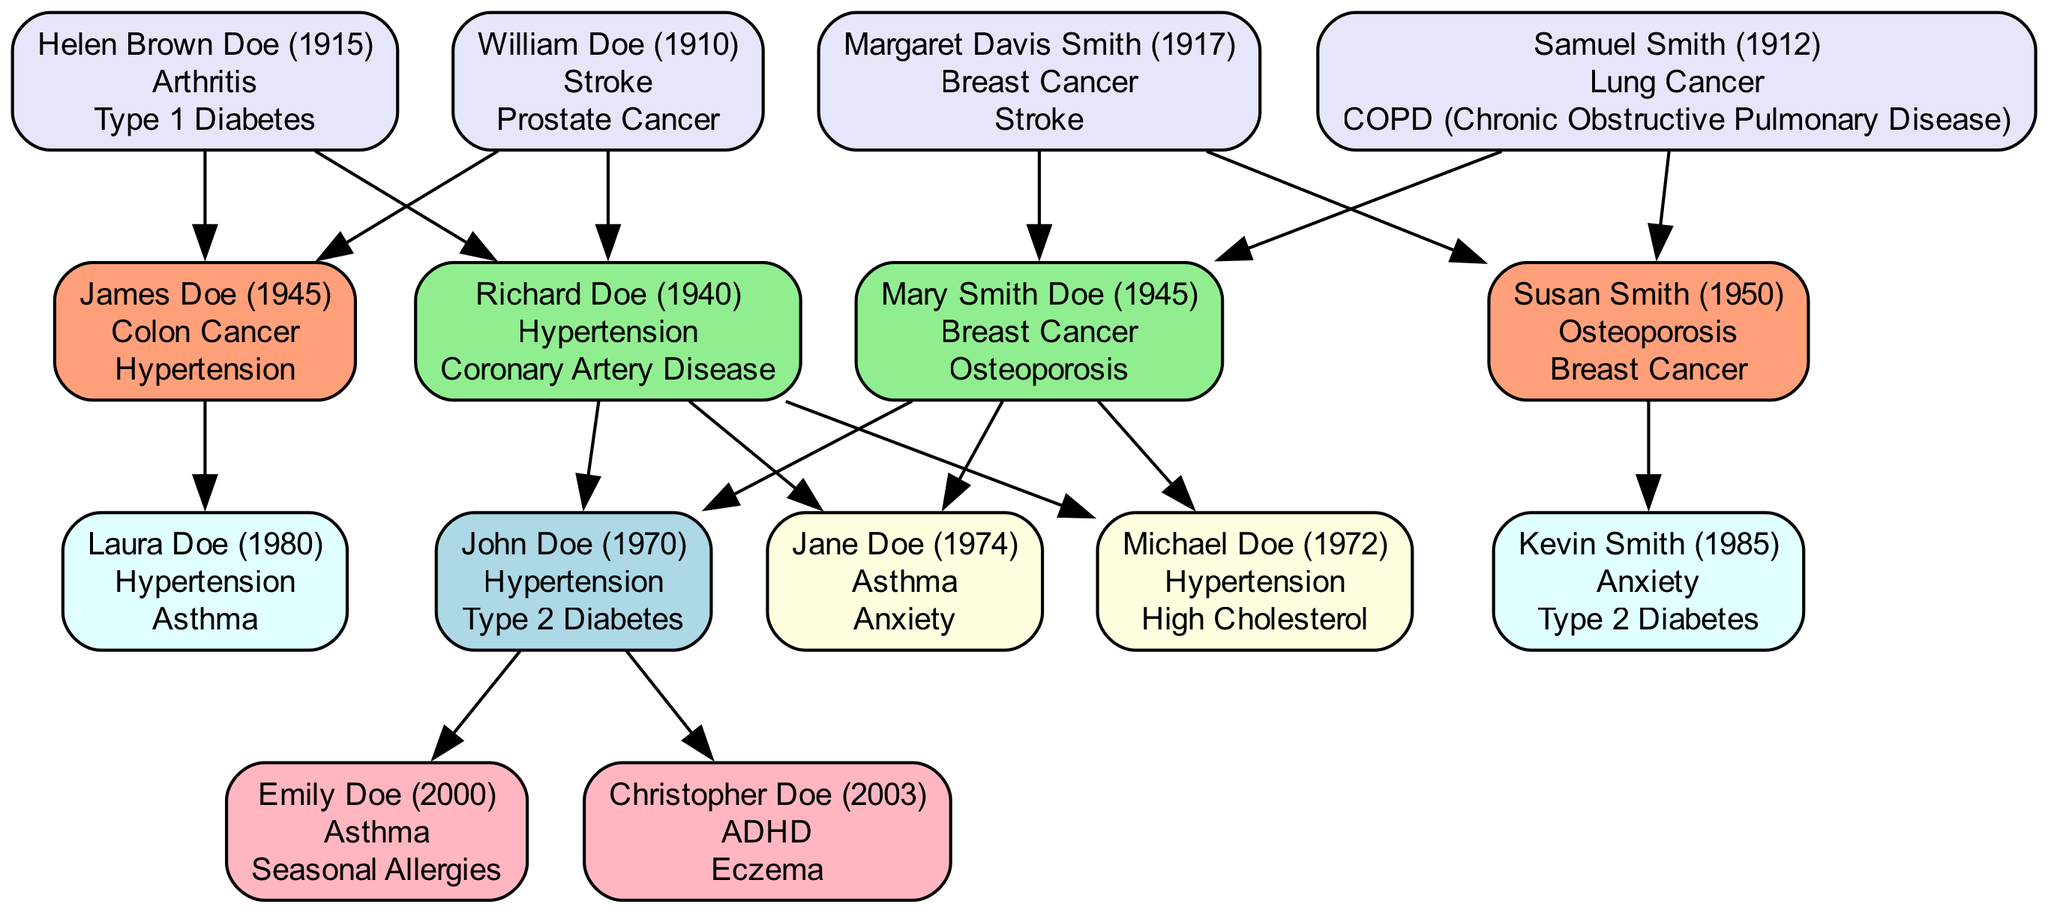What's the birth year of John Doe? The diagram shows John Doe's information in the root node. It lists his name and birth year, which is 1970.
Answer: 1970 How many medical conditions does Mary Smith Doe have? By examining the node for Mary Smith Doe, it states she has two medical conditions: Breast Cancer and Osteoporosis.
Answer: 2 Which sibling has Asthma? Looking at the siblings' nodes, Jane Doe is listed with the medical conditions Asthma and Anxiety.
Answer: Jane Doe What medical conditions are shared by John Doe and his father? Both John Doe and his father, Richard Doe, have Hypertension listed in their medical conditions. This shows a shared hereditary health risk.
Answer: Hypertension How many total children does John Doe have? The diagram includes two children nodes, Emily Doe and Christopher Doe, under John Doe, indicating he has two children.
Answer: 2 Which grandparent had a medical condition related to cancer? Helen Brown Doe and Margaret Davis Smith are identified as having medical conditions of Type 1 Diabetes and Breast Cancer, respectively. Since "Breast Cancer" is a type of cancer, Margaret Davis Smith fits this criterion.
Answer: Margaret Davis Smith What is the relationship of Kevin Smith to John Doe? Kevin Smith is listed as a cousin in the cousins' section which connects back to John Doe's maternal side from his mother's side, thus making him John Doe's cousin.
Answer: Cousin Which parent has a sibling named Susan Smith? The node shows Susan Smith is listed as a maternal aunt, indicating she is the sister of John Doe's mother, Mary Smith Doe.
Answer: Mother How many aunts or uncles does John Doe have? The diagram lists two aunts/uncles: James Doe and Susan Smith, showing that John Doe has a total of two aunts/uncles.
Answer: 2 